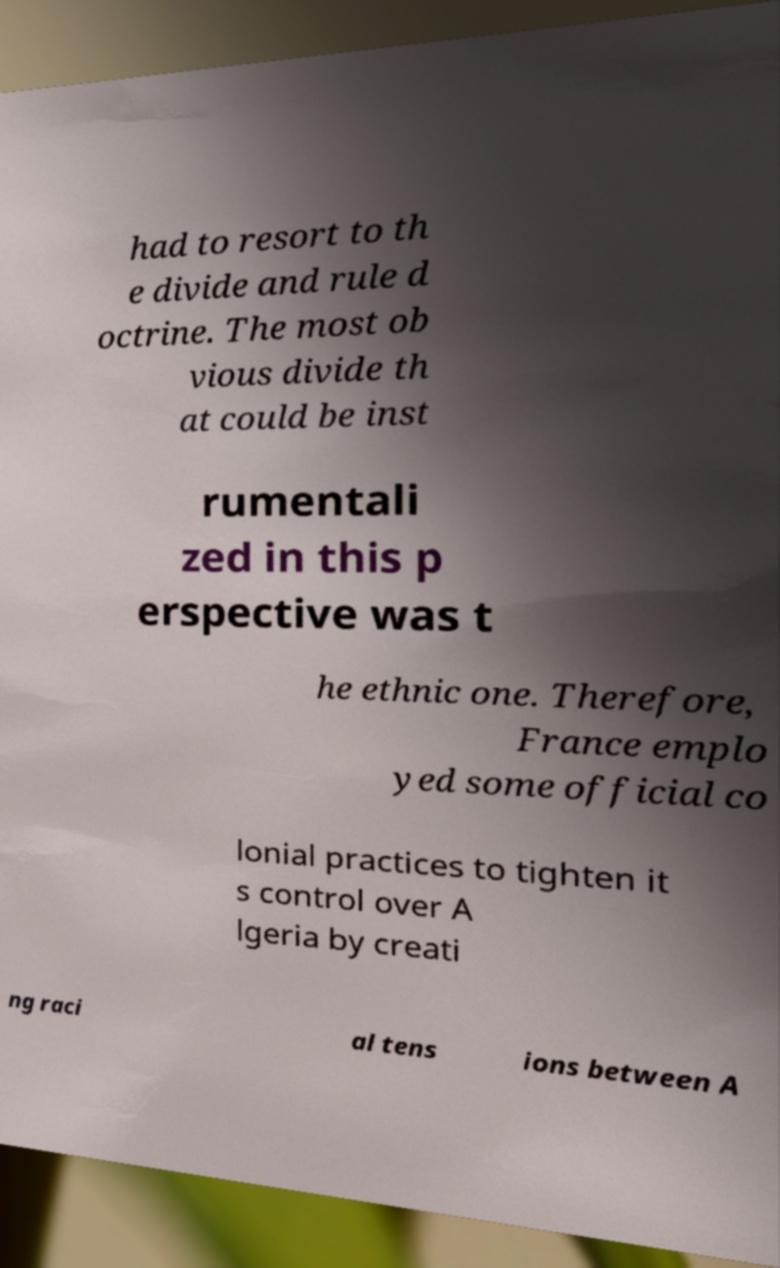Can you accurately transcribe the text from the provided image for me? had to resort to th e divide and rule d octrine. The most ob vious divide th at could be inst rumentali zed in this p erspective was t he ethnic one. Therefore, France emplo yed some official co lonial practices to tighten it s control over A lgeria by creati ng raci al tens ions between A 